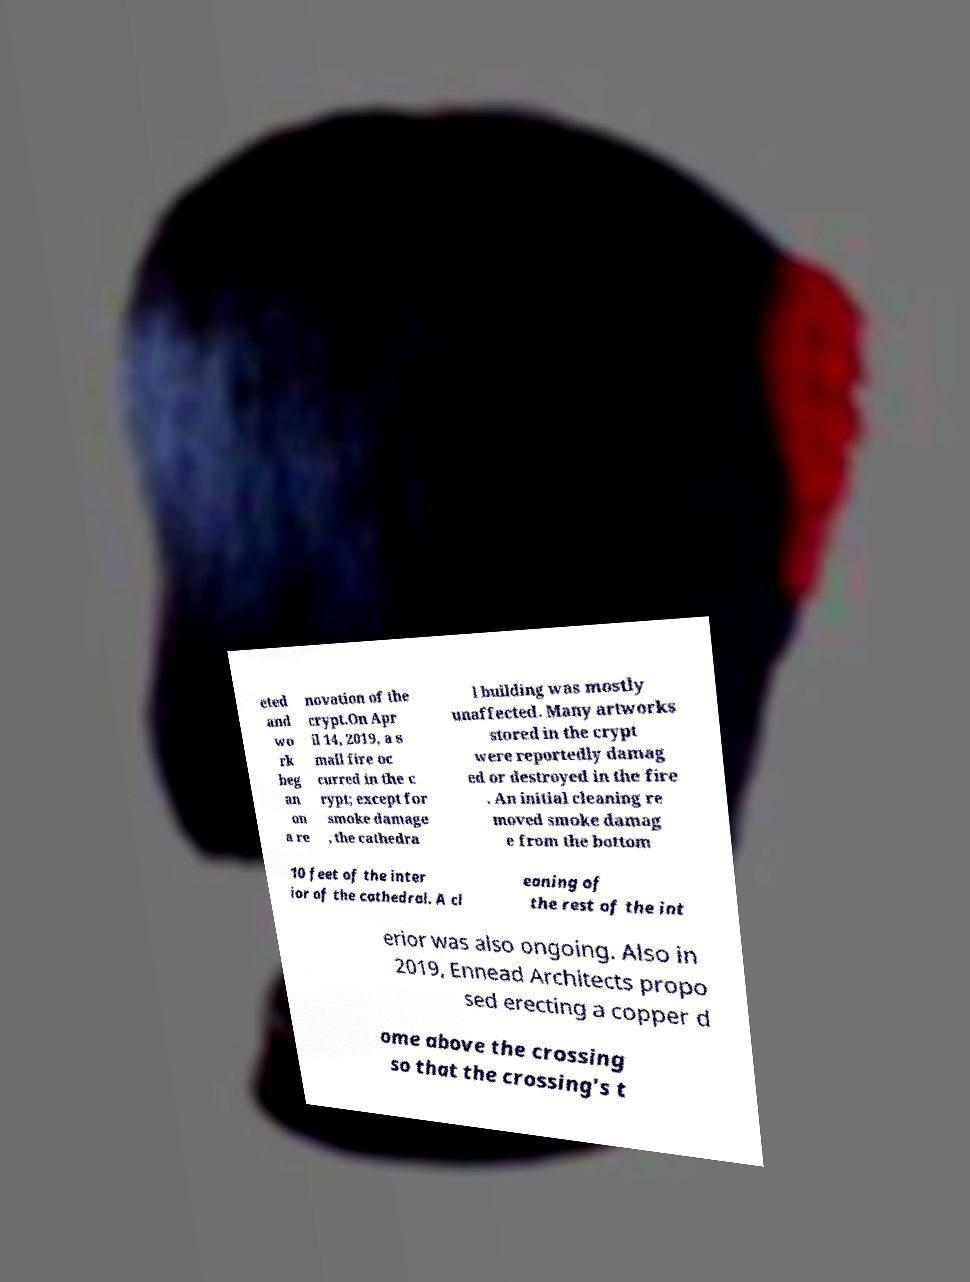I need the written content from this picture converted into text. Can you do that? eted and wo rk beg an on a re novation of the crypt.On Apr il 14, 2019, a s mall fire oc curred in the c rypt; except for smoke damage , the cathedra l building was mostly unaffected. Many artworks stored in the crypt were reportedly damag ed or destroyed in the fire . An initial cleaning re moved smoke damag e from the bottom 10 feet of the inter ior of the cathedral. A cl eaning of the rest of the int erior was also ongoing. Also in 2019, Ennead Architects propo sed erecting a copper d ome above the crossing so that the crossing's t 